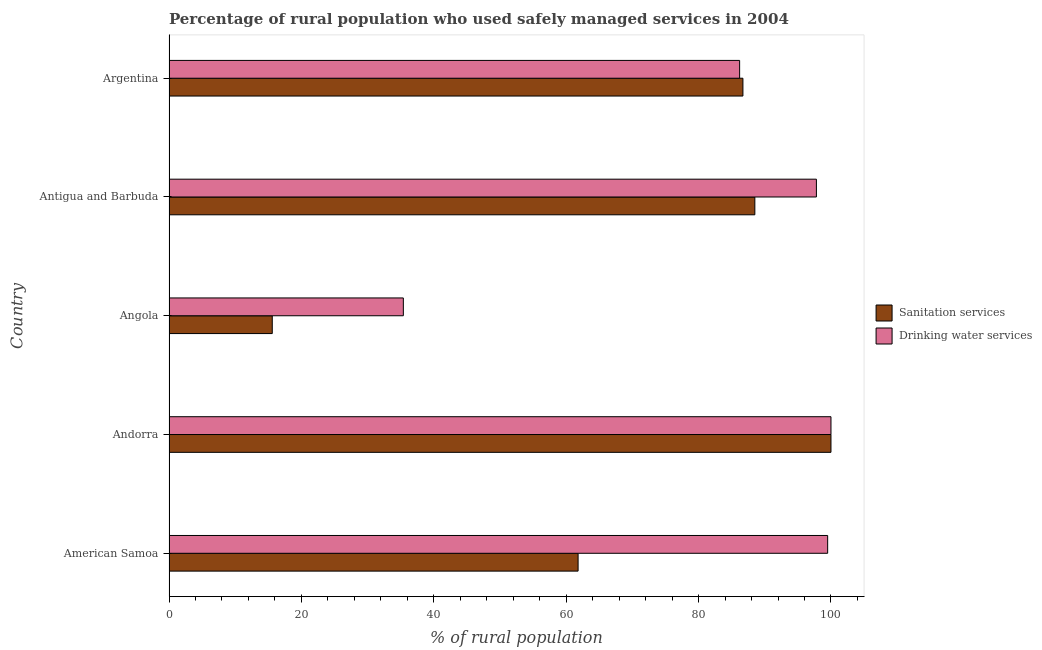Are the number of bars per tick equal to the number of legend labels?
Make the answer very short. Yes. How many bars are there on the 1st tick from the top?
Give a very brief answer. 2. How many bars are there on the 4th tick from the bottom?
Your response must be concise. 2. What is the label of the 4th group of bars from the top?
Offer a very short reply. Andorra. What is the percentage of rural population who used drinking water services in Antigua and Barbuda?
Your answer should be compact. 97.8. Across all countries, what is the minimum percentage of rural population who used drinking water services?
Keep it short and to the point. 35.4. In which country was the percentage of rural population who used sanitation services maximum?
Your answer should be very brief. Andorra. In which country was the percentage of rural population who used drinking water services minimum?
Ensure brevity in your answer.  Angola. What is the total percentage of rural population who used sanitation services in the graph?
Ensure brevity in your answer.  352.6. What is the difference between the percentage of rural population who used drinking water services in American Samoa and that in Angola?
Keep it short and to the point. 64.1. What is the difference between the percentage of rural population who used drinking water services in Angola and the percentage of rural population who used sanitation services in Antigua and Barbuda?
Keep it short and to the point. -53.1. What is the average percentage of rural population who used drinking water services per country?
Provide a succinct answer. 83.78. What is the difference between the percentage of rural population who used drinking water services and percentage of rural population who used sanitation services in Antigua and Barbuda?
Offer a terse response. 9.3. What is the ratio of the percentage of rural population who used drinking water services in Andorra to that in Angola?
Provide a succinct answer. 2.83. Is the difference between the percentage of rural population who used drinking water services in Angola and Antigua and Barbuda greater than the difference between the percentage of rural population who used sanitation services in Angola and Antigua and Barbuda?
Your response must be concise. Yes. What is the difference between the highest and the lowest percentage of rural population who used sanitation services?
Offer a very short reply. 84.4. What does the 2nd bar from the top in Angola represents?
Keep it short and to the point. Sanitation services. What does the 1st bar from the bottom in Andorra represents?
Your response must be concise. Sanitation services. How many countries are there in the graph?
Offer a terse response. 5. Does the graph contain grids?
Your answer should be compact. No. Where does the legend appear in the graph?
Give a very brief answer. Center right. How many legend labels are there?
Make the answer very short. 2. What is the title of the graph?
Offer a very short reply. Percentage of rural population who used safely managed services in 2004. What is the label or title of the X-axis?
Keep it short and to the point. % of rural population. What is the label or title of the Y-axis?
Ensure brevity in your answer.  Country. What is the % of rural population of Sanitation services in American Samoa?
Your answer should be very brief. 61.8. What is the % of rural population in Drinking water services in American Samoa?
Keep it short and to the point. 99.5. What is the % of rural population of Drinking water services in Angola?
Keep it short and to the point. 35.4. What is the % of rural population in Sanitation services in Antigua and Barbuda?
Your answer should be compact. 88.5. What is the % of rural population of Drinking water services in Antigua and Barbuda?
Offer a terse response. 97.8. What is the % of rural population of Sanitation services in Argentina?
Your answer should be compact. 86.7. What is the % of rural population of Drinking water services in Argentina?
Ensure brevity in your answer.  86.2. Across all countries, what is the maximum % of rural population of Sanitation services?
Your answer should be very brief. 100. Across all countries, what is the minimum % of rural population of Drinking water services?
Your answer should be compact. 35.4. What is the total % of rural population in Sanitation services in the graph?
Offer a terse response. 352.6. What is the total % of rural population of Drinking water services in the graph?
Your response must be concise. 418.9. What is the difference between the % of rural population in Sanitation services in American Samoa and that in Andorra?
Offer a very short reply. -38.2. What is the difference between the % of rural population of Drinking water services in American Samoa and that in Andorra?
Offer a very short reply. -0.5. What is the difference between the % of rural population of Sanitation services in American Samoa and that in Angola?
Make the answer very short. 46.2. What is the difference between the % of rural population in Drinking water services in American Samoa and that in Angola?
Make the answer very short. 64.1. What is the difference between the % of rural population of Sanitation services in American Samoa and that in Antigua and Barbuda?
Offer a terse response. -26.7. What is the difference between the % of rural population of Drinking water services in American Samoa and that in Antigua and Barbuda?
Ensure brevity in your answer.  1.7. What is the difference between the % of rural population in Sanitation services in American Samoa and that in Argentina?
Ensure brevity in your answer.  -24.9. What is the difference between the % of rural population in Sanitation services in Andorra and that in Angola?
Ensure brevity in your answer.  84.4. What is the difference between the % of rural population in Drinking water services in Andorra and that in Angola?
Your answer should be very brief. 64.6. What is the difference between the % of rural population in Drinking water services in Andorra and that in Antigua and Barbuda?
Provide a succinct answer. 2.2. What is the difference between the % of rural population in Sanitation services in Angola and that in Antigua and Barbuda?
Provide a succinct answer. -72.9. What is the difference between the % of rural population of Drinking water services in Angola and that in Antigua and Barbuda?
Your answer should be very brief. -62.4. What is the difference between the % of rural population of Sanitation services in Angola and that in Argentina?
Keep it short and to the point. -71.1. What is the difference between the % of rural population in Drinking water services in Angola and that in Argentina?
Offer a terse response. -50.8. What is the difference between the % of rural population of Drinking water services in Antigua and Barbuda and that in Argentina?
Keep it short and to the point. 11.6. What is the difference between the % of rural population of Sanitation services in American Samoa and the % of rural population of Drinking water services in Andorra?
Ensure brevity in your answer.  -38.2. What is the difference between the % of rural population in Sanitation services in American Samoa and the % of rural population in Drinking water services in Angola?
Ensure brevity in your answer.  26.4. What is the difference between the % of rural population of Sanitation services in American Samoa and the % of rural population of Drinking water services in Antigua and Barbuda?
Ensure brevity in your answer.  -36. What is the difference between the % of rural population of Sanitation services in American Samoa and the % of rural population of Drinking water services in Argentina?
Your answer should be compact. -24.4. What is the difference between the % of rural population of Sanitation services in Andorra and the % of rural population of Drinking water services in Angola?
Provide a short and direct response. 64.6. What is the difference between the % of rural population in Sanitation services in Angola and the % of rural population in Drinking water services in Antigua and Barbuda?
Keep it short and to the point. -82.2. What is the difference between the % of rural population of Sanitation services in Angola and the % of rural population of Drinking water services in Argentina?
Ensure brevity in your answer.  -70.6. What is the difference between the % of rural population of Sanitation services in Antigua and Barbuda and the % of rural population of Drinking water services in Argentina?
Provide a succinct answer. 2.3. What is the average % of rural population of Sanitation services per country?
Make the answer very short. 70.52. What is the average % of rural population in Drinking water services per country?
Make the answer very short. 83.78. What is the difference between the % of rural population of Sanitation services and % of rural population of Drinking water services in American Samoa?
Offer a very short reply. -37.7. What is the difference between the % of rural population of Sanitation services and % of rural population of Drinking water services in Angola?
Your answer should be compact. -19.8. What is the difference between the % of rural population in Sanitation services and % of rural population in Drinking water services in Antigua and Barbuda?
Give a very brief answer. -9.3. What is the difference between the % of rural population in Sanitation services and % of rural population in Drinking water services in Argentina?
Your response must be concise. 0.5. What is the ratio of the % of rural population of Sanitation services in American Samoa to that in Andorra?
Offer a terse response. 0.62. What is the ratio of the % of rural population of Sanitation services in American Samoa to that in Angola?
Keep it short and to the point. 3.96. What is the ratio of the % of rural population of Drinking water services in American Samoa to that in Angola?
Give a very brief answer. 2.81. What is the ratio of the % of rural population in Sanitation services in American Samoa to that in Antigua and Barbuda?
Give a very brief answer. 0.7. What is the ratio of the % of rural population in Drinking water services in American Samoa to that in Antigua and Barbuda?
Your answer should be very brief. 1.02. What is the ratio of the % of rural population in Sanitation services in American Samoa to that in Argentina?
Provide a succinct answer. 0.71. What is the ratio of the % of rural population of Drinking water services in American Samoa to that in Argentina?
Offer a terse response. 1.15. What is the ratio of the % of rural population of Sanitation services in Andorra to that in Angola?
Offer a very short reply. 6.41. What is the ratio of the % of rural population in Drinking water services in Andorra to that in Angola?
Give a very brief answer. 2.82. What is the ratio of the % of rural population in Sanitation services in Andorra to that in Antigua and Barbuda?
Give a very brief answer. 1.13. What is the ratio of the % of rural population in Drinking water services in Andorra to that in Antigua and Barbuda?
Ensure brevity in your answer.  1.02. What is the ratio of the % of rural population in Sanitation services in Andorra to that in Argentina?
Keep it short and to the point. 1.15. What is the ratio of the % of rural population of Drinking water services in Andorra to that in Argentina?
Make the answer very short. 1.16. What is the ratio of the % of rural population in Sanitation services in Angola to that in Antigua and Barbuda?
Give a very brief answer. 0.18. What is the ratio of the % of rural population in Drinking water services in Angola to that in Antigua and Barbuda?
Make the answer very short. 0.36. What is the ratio of the % of rural population in Sanitation services in Angola to that in Argentina?
Provide a short and direct response. 0.18. What is the ratio of the % of rural population in Drinking water services in Angola to that in Argentina?
Provide a succinct answer. 0.41. What is the ratio of the % of rural population of Sanitation services in Antigua and Barbuda to that in Argentina?
Provide a short and direct response. 1.02. What is the ratio of the % of rural population of Drinking water services in Antigua and Barbuda to that in Argentina?
Ensure brevity in your answer.  1.13. What is the difference between the highest and the lowest % of rural population of Sanitation services?
Keep it short and to the point. 84.4. What is the difference between the highest and the lowest % of rural population of Drinking water services?
Keep it short and to the point. 64.6. 